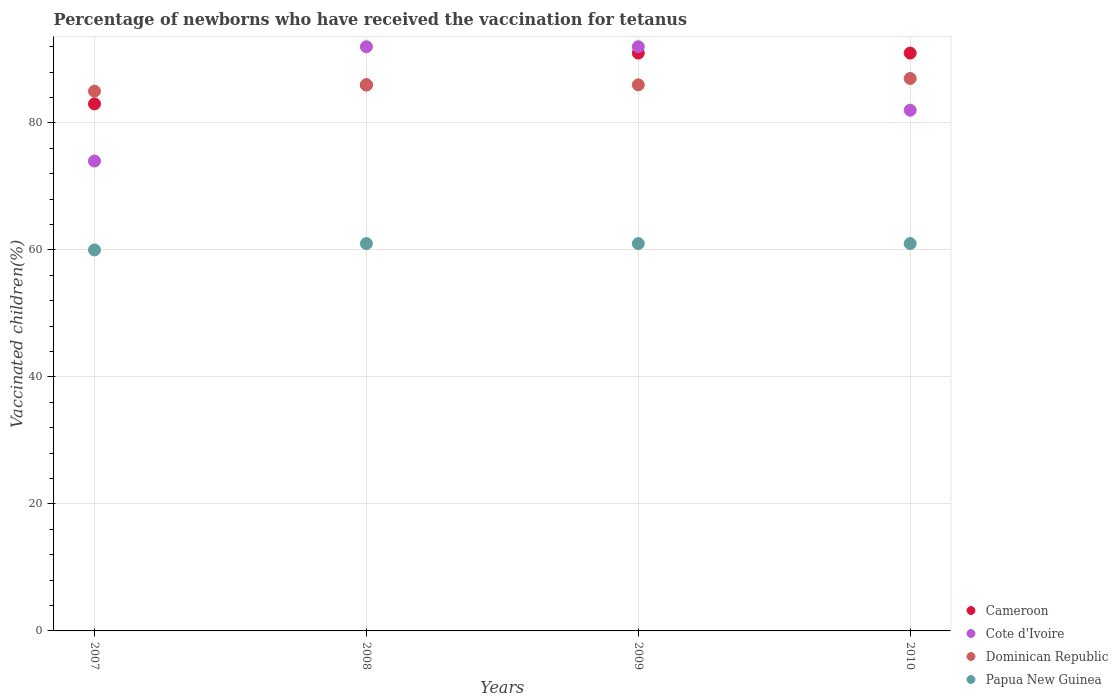What is the percentage of vaccinated children in Cote d'Ivoire in 2008?
Give a very brief answer. 92. Across all years, what is the maximum percentage of vaccinated children in Cote d'Ivoire?
Offer a very short reply. 92. Across all years, what is the minimum percentage of vaccinated children in Cameroon?
Keep it short and to the point. 83. In which year was the percentage of vaccinated children in Dominican Republic minimum?
Make the answer very short. 2007. What is the total percentage of vaccinated children in Cameroon in the graph?
Your answer should be very brief. 351. What is the difference between the percentage of vaccinated children in Dominican Republic in 2009 and the percentage of vaccinated children in Papua New Guinea in 2007?
Your answer should be very brief. 26. What is the average percentage of vaccinated children in Dominican Republic per year?
Keep it short and to the point. 86. In the year 2009, what is the difference between the percentage of vaccinated children in Cote d'Ivoire and percentage of vaccinated children in Papua New Guinea?
Ensure brevity in your answer.  31. In how many years, is the percentage of vaccinated children in Papua New Guinea greater than 52 %?
Give a very brief answer. 4. What is the ratio of the percentage of vaccinated children in Papua New Guinea in 2007 to that in 2009?
Make the answer very short. 0.98. Is the difference between the percentage of vaccinated children in Cote d'Ivoire in 2008 and 2009 greater than the difference between the percentage of vaccinated children in Papua New Guinea in 2008 and 2009?
Your answer should be compact. No. What is the difference between the highest and the second highest percentage of vaccinated children in Cote d'Ivoire?
Ensure brevity in your answer.  0. What is the difference between the highest and the lowest percentage of vaccinated children in Cote d'Ivoire?
Ensure brevity in your answer.  18. Is the sum of the percentage of vaccinated children in Papua New Guinea in 2007 and 2010 greater than the maximum percentage of vaccinated children in Dominican Republic across all years?
Give a very brief answer. Yes. Is it the case that in every year, the sum of the percentage of vaccinated children in Dominican Republic and percentage of vaccinated children in Papua New Guinea  is greater than the sum of percentage of vaccinated children in Cote d'Ivoire and percentage of vaccinated children in Cameroon?
Keep it short and to the point. Yes. Is the percentage of vaccinated children in Cote d'Ivoire strictly greater than the percentage of vaccinated children in Papua New Guinea over the years?
Offer a terse response. Yes. Is the percentage of vaccinated children in Cameroon strictly less than the percentage of vaccinated children in Papua New Guinea over the years?
Keep it short and to the point. No. What is the difference between two consecutive major ticks on the Y-axis?
Provide a succinct answer. 20. Are the values on the major ticks of Y-axis written in scientific E-notation?
Make the answer very short. No. Does the graph contain any zero values?
Your answer should be compact. No. How many legend labels are there?
Provide a short and direct response. 4. What is the title of the graph?
Keep it short and to the point. Percentage of newborns who have received the vaccination for tetanus. Does "Bangladesh" appear as one of the legend labels in the graph?
Your answer should be very brief. No. What is the label or title of the Y-axis?
Keep it short and to the point. Vaccinated children(%). What is the Vaccinated children(%) of Cote d'Ivoire in 2007?
Provide a short and direct response. 74. What is the Vaccinated children(%) of Cameroon in 2008?
Offer a terse response. 86. What is the Vaccinated children(%) of Cote d'Ivoire in 2008?
Keep it short and to the point. 92. What is the Vaccinated children(%) in Papua New Guinea in 2008?
Keep it short and to the point. 61. What is the Vaccinated children(%) of Cameroon in 2009?
Offer a terse response. 91. What is the Vaccinated children(%) in Cote d'Ivoire in 2009?
Offer a very short reply. 92. What is the Vaccinated children(%) in Cameroon in 2010?
Make the answer very short. 91. What is the Vaccinated children(%) in Cote d'Ivoire in 2010?
Make the answer very short. 82. What is the Vaccinated children(%) in Dominican Republic in 2010?
Give a very brief answer. 87. Across all years, what is the maximum Vaccinated children(%) in Cameroon?
Make the answer very short. 91. Across all years, what is the maximum Vaccinated children(%) in Cote d'Ivoire?
Provide a succinct answer. 92. Across all years, what is the minimum Vaccinated children(%) of Cote d'Ivoire?
Offer a very short reply. 74. Across all years, what is the minimum Vaccinated children(%) of Dominican Republic?
Provide a short and direct response. 85. Across all years, what is the minimum Vaccinated children(%) of Papua New Guinea?
Keep it short and to the point. 60. What is the total Vaccinated children(%) in Cameroon in the graph?
Offer a terse response. 351. What is the total Vaccinated children(%) of Cote d'Ivoire in the graph?
Your answer should be compact. 340. What is the total Vaccinated children(%) of Dominican Republic in the graph?
Ensure brevity in your answer.  344. What is the total Vaccinated children(%) in Papua New Guinea in the graph?
Keep it short and to the point. 243. What is the difference between the Vaccinated children(%) of Cameroon in 2007 and that in 2008?
Your response must be concise. -3. What is the difference between the Vaccinated children(%) of Dominican Republic in 2007 and that in 2008?
Your response must be concise. -1. What is the difference between the Vaccinated children(%) in Papua New Guinea in 2007 and that in 2009?
Offer a very short reply. -1. What is the difference between the Vaccinated children(%) in Cote d'Ivoire in 2007 and that in 2010?
Your answer should be very brief. -8. What is the difference between the Vaccinated children(%) of Dominican Republic in 2007 and that in 2010?
Give a very brief answer. -2. What is the difference between the Vaccinated children(%) of Papua New Guinea in 2007 and that in 2010?
Keep it short and to the point. -1. What is the difference between the Vaccinated children(%) in Cameroon in 2008 and that in 2009?
Give a very brief answer. -5. What is the difference between the Vaccinated children(%) in Cote d'Ivoire in 2008 and that in 2009?
Provide a succinct answer. 0. What is the difference between the Vaccinated children(%) of Dominican Republic in 2008 and that in 2009?
Provide a short and direct response. 0. What is the difference between the Vaccinated children(%) in Papua New Guinea in 2008 and that in 2009?
Give a very brief answer. 0. What is the difference between the Vaccinated children(%) of Cote d'Ivoire in 2008 and that in 2010?
Give a very brief answer. 10. What is the difference between the Vaccinated children(%) of Papua New Guinea in 2008 and that in 2010?
Your response must be concise. 0. What is the difference between the Vaccinated children(%) of Dominican Republic in 2009 and that in 2010?
Ensure brevity in your answer.  -1. What is the difference between the Vaccinated children(%) in Papua New Guinea in 2009 and that in 2010?
Your answer should be compact. 0. What is the difference between the Vaccinated children(%) of Cameroon in 2007 and the Vaccinated children(%) of Papua New Guinea in 2008?
Offer a terse response. 22. What is the difference between the Vaccinated children(%) of Dominican Republic in 2007 and the Vaccinated children(%) of Papua New Guinea in 2009?
Give a very brief answer. 24. What is the difference between the Vaccinated children(%) of Cameroon in 2007 and the Vaccinated children(%) of Dominican Republic in 2010?
Your answer should be compact. -4. What is the difference between the Vaccinated children(%) in Cameroon in 2008 and the Vaccinated children(%) in Cote d'Ivoire in 2009?
Offer a terse response. -6. What is the difference between the Vaccinated children(%) in Cameroon in 2008 and the Vaccinated children(%) in Dominican Republic in 2009?
Your answer should be compact. 0. What is the difference between the Vaccinated children(%) in Dominican Republic in 2008 and the Vaccinated children(%) in Papua New Guinea in 2009?
Your answer should be very brief. 25. What is the difference between the Vaccinated children(%) in Cameroon in 2008 and the Vaccinated children(%) in Cote d'Ivoire in 2010?
Your response must be concise. 4. What is the difference between the Vaccinated children(%) of Cote d'Ivoire in 2008 and the Vaccinated children(%) of Dominican Republic in 2010?
Give a very brief answer. 5. What is the difference between the Vaccinated children(%) of Cote d'Ivoire in 2008 and the Vaccinated children(%) of Papua New Guinea in 2010?
Your answer should be compact. 31. What is the difference between the Vaccinated children(%) in Cote d'Ivoire in 2009 and the Vaccinated children(%) in Papua New Guinea in 2010?
Offer a very short reply. 31. What is the average Vaccinated children(%) of Cameroon per year?
Keep it short and to the point. 87.75. What is the average Vaccinated children(%) in Cote d'Ivoire per year?
Offer a very short reply. 85. What is the average Vaccinated children(%) in Papua New Guinea per year?
Offer a terse response. 60.75. In the year 2007, what is the difference between the Vaccinated children(%) of Cameroon and Vaccinated children(%) of Cote d'Ivoire?
Provide a succinct answer. 9. In the year 2007, what is the difference between the Vaccinated children(%) in Cote d'Ivoire and Vaccinated children(%) in Papua New Guinea?
Make the answer very short. 14. In the year 2007, what is the difference between the Vaccinated children(%) in Dominican Republic and Vaccinated children(%) in Papua New Guinea?
Your answer should be compact. 25. In the year 2008, what is the difference between the Vaccinated children(%) in Cameroon and Vaccinated children(%) in Papua New Guinea?
Offer a very short reply. 25. In the year 2009, what is the difference between the Vaccinated children(%) of Cameroon and Vaccinated children(%) of Dominican Republic?
Provide a succinct answer. 5. In the year 2009, what is the difference between the Vaccinated children(%) in Cameroon and Vaccinated children(%) in Papua New Guinea?
Make the answer very short. 30. In the year 2009, what is the difference between the Vaccinated children(%) of Cote d'Ivoire and Vaccinated children(%) of Dominican Republic?
Offer a very short reply. 6. In the year 2009, what is the difference between the Vaccinated children(%) in Cote d'Ivoire and Vaccinated children(%) in Papua New Guinea?
Make the answer very short. 31. In the year 2009, what is the difference between the Vaccinated children(%) in Dominican Republic and Vaccinated children(%) in Papua New Guinea?
Offer a terse response. 25. In the year 2010, what is the difference between the Vaccinated children(%) of Cameroon and Vaccinated children(%) of Dominican Republic?
Keep it short and to the point. 4. In the year 2010, what is the difference between the Vaccinated children(%) in Cameroon and Vaccinated children(%) in Papua New Guinea?
Ensure brevity in your answer.  30. In the year 2010, what is the difference between the Vaccinated children(%) in Dominican Republic and Vaccinated children(%) in Papua New Guinea?
Your response must be concise. 26. What is the ratio of the Vaccinated children(%) in Cameroon in 2007 to that in 2008?
Make the answer very short. 0.97. What is the ratio of the Vaccinated children(%) of Cote d'Ivoire in 2007 to that in 2008?
Make the answer very short. 0.8. What is the ratio of the Vaccinated children(%) of Dominican Republic in 2007 to that in 2008?
Offer a very short reply. 0.99. What is the ratio of the Vaccinated children(%) in Papua New Guinea in 2007 to that in 2008?
Provide a succinct answer. 0.98. What is the ratio of the Vaccinated children(%) in Cameroon in 2007 to that in 2009?
Offer a very short reply. 0.91. What is the ratio of the Vaccinated children(%) of Cote d'Ivoire in 2007 to that in 2009?
Offer a terse response. 0.8. What is the ratio of the Vaccinated children(%) in Dominican Republic in 2007 to that in 2009?
Your response must be concise. 0.99. What is the ratio of the Vaccinated children(%) of Papua New Guinea in 2007 to that in 2009?
Give a very brief answer. 0.98. What is the ratio of the Vaccinated children(%) in Cameroon in 2007 to that in 2010?
Make the answer very short. 0.91. What is the ratio of the Vaccinated children(%) of Cote d'Ivoire in 2007 to that in 2010?
Provide a short and direct response. 0.9. What is the ratio of the Vaccinated children(%) of Dominican Republic in 2007 to that in 2010?
Keep it short and to the point. 0.98. What is the ratio of the Vaccinated children(%) of Papua New Guinea in 2007 to that in 2010?
Provide a succinct answer. 0.98. What is the ratio of the Vaccinated children(%) of Cameroon in 2008 to that in 2009?
Give a very brief answer. 0.95. What is the ratio of the Vaccinated children(%) of Cote d'Ivoire in 2008 to that in 2009?
Make the answer very short. 1. What is the ratio of the Vaccinated children(%) in Dominican Republic in 2008 to that in 2009?
Provide a short and direct response. 1. What is the ratio of the Vaccinated children(%) of Cameroon in 2008 to that in 2010?
Offer a very short reply. 0.95. What is the ratio of the Vaccinated children(%) in Cote d'Ivoire in 2008 to that in 2010?
Offer a very short reply. 1.12. What is the ratio of the Vaccinated children(%) in Dominican Republic in 2008 to that in 2010?
Keep it short and to the point. 0.99. What is the ratio of the Vaccinated children(%) of Cote d'Ivoire in 2009 to that in 2010?
Offer a terse response. 1.12. What is the ratio of the Vaccinated children(%) in Papua New Guinea in 2009 to that in 2010?
Provide a succinct answer. 1. What is the difference between the highest and the second highest Vaccinated children(%) in Papua New Guinea?
Provide a succinct answer. 0. What is the difference between the highest and the lowest Vaccinated children(%) of Cameroon?
Your answer should be compact. 8. What is the difference between the highest and the lowest Vaccinated children(%) in Cote d'Ivoire?
Make the answer very short. 18. 